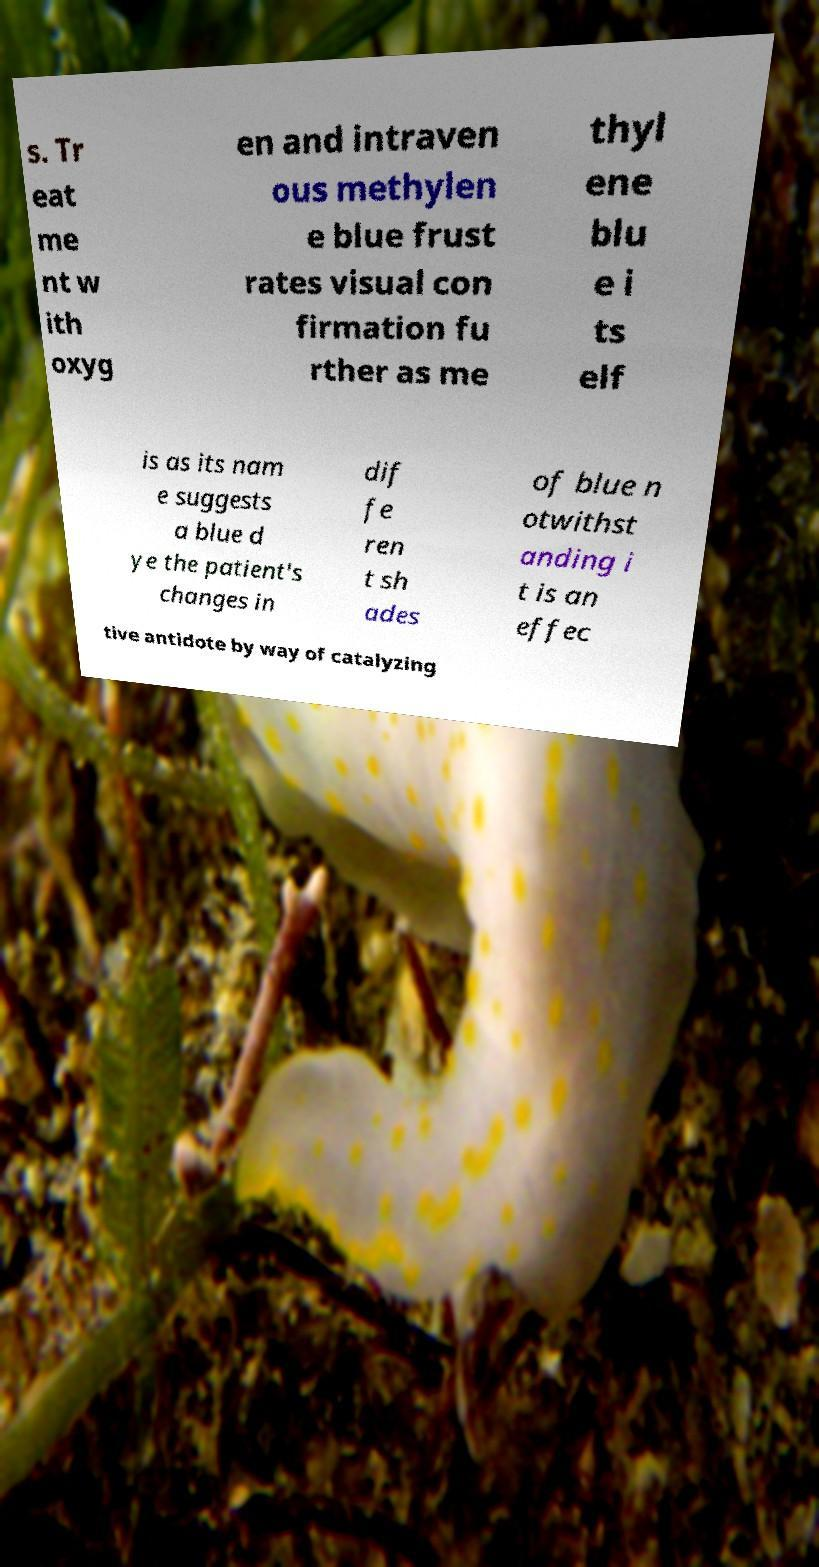Could you assist in decoding the text presented in this image and type it out clearly? s. Tr eat me nt w ith oxyg en and intraven ous methylen e blue frust rates visual con firmation fu rther as me thyl ene blu e i ts elf is as its nam e suggests a blue d ye the patient's changes in dif fe ren t sh ades of blue n otwithst anding i t is an effec tive antidote by way of catalyzing 